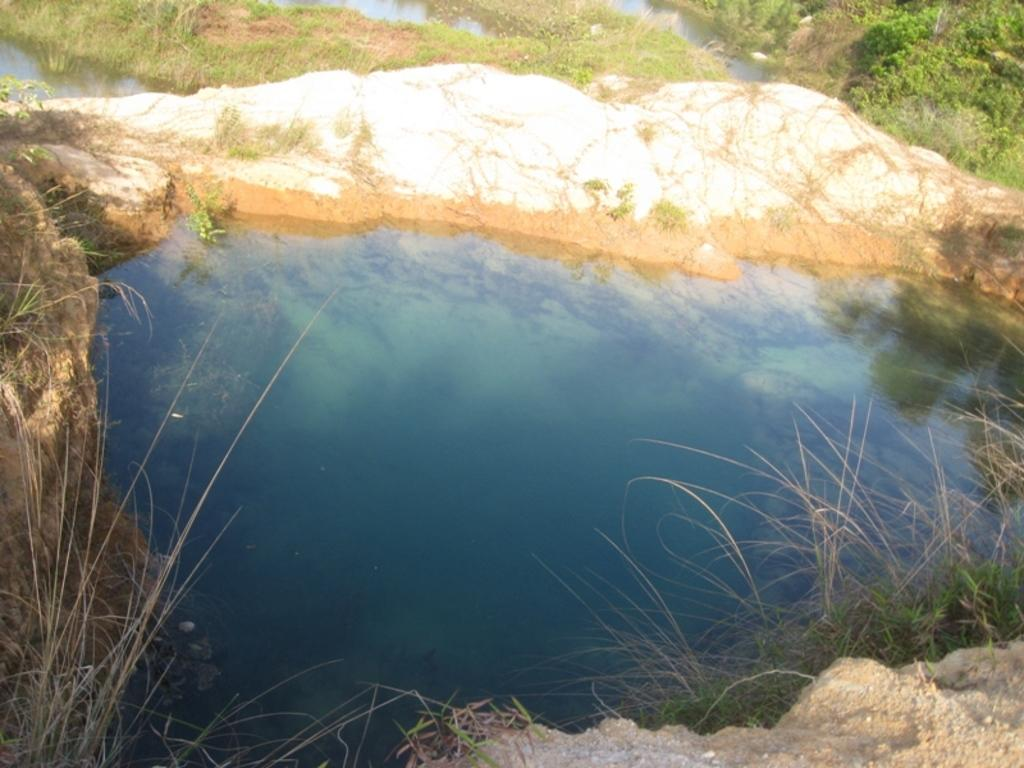What is the main feature in the center of the image? There is a pond in the center of the image. What can be seen surrounding the pond? There are plants, grass, and stones surrounding the pond. Where is the lunchroom located in the image? There is no lunchroom present in the image; it features a pond surrounded by plants, grass, and stones. 